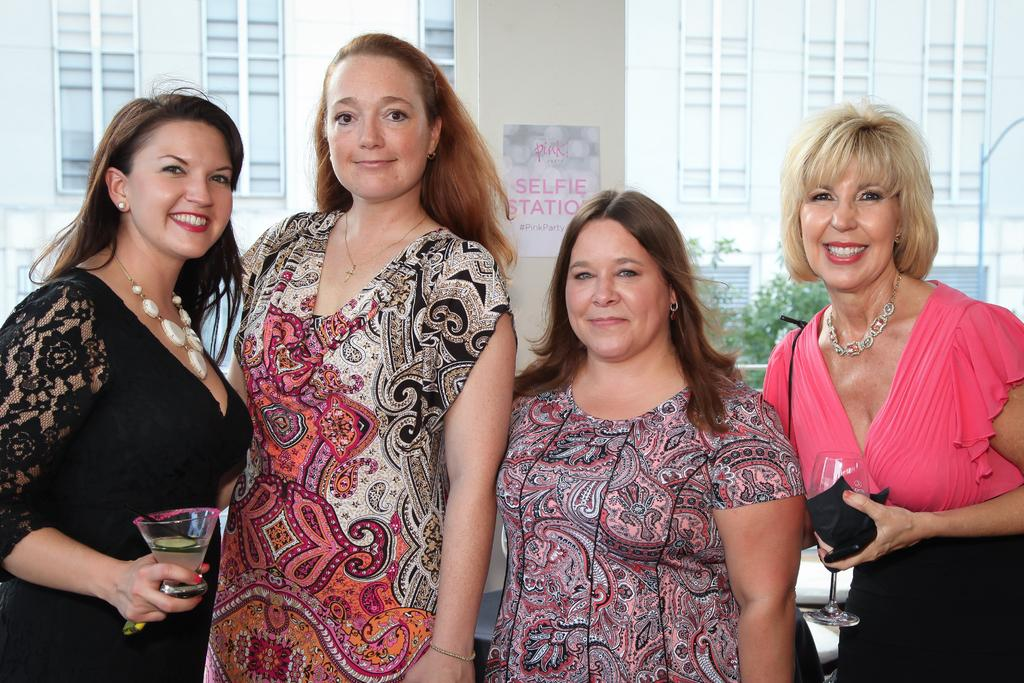How many women are present in the image? There are four women in the image. What are two of the women holding? Two of the women are holding a glass of drink. What architectural feature can be seen in the image? There is a pillar visible in the image. What can be seen in the background of the image? There is a building and a tree in the background of the image. What type of cookware is being used by the women in the image? There is no cookware present in the image; the women are holding glasses of drink. How many bombs can be seen in the image? There are no bombs present in the image; it features four women and a pillar. 